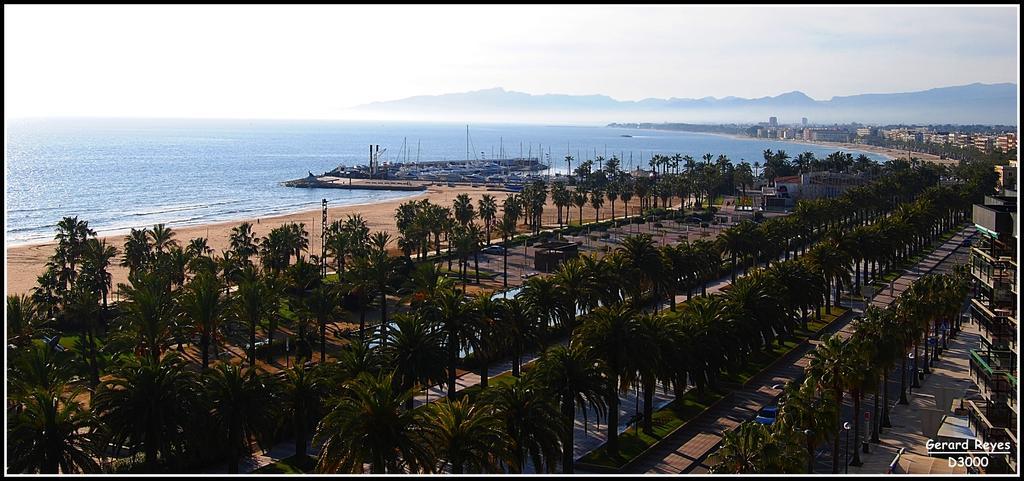Can you describe this image briefly? In this picture we can see trees in the front, on the left side there is water, we can see some boats here, in the background there are some buildings, we can see the sky at the top of the picture, at the bottom there is grass, at the right bottom we can see some text. 